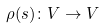Convert formula to latex. <formula><loc_0><loc_0><loc_500><loc_500>\rho ( s ) \colon V \to V</formula> 